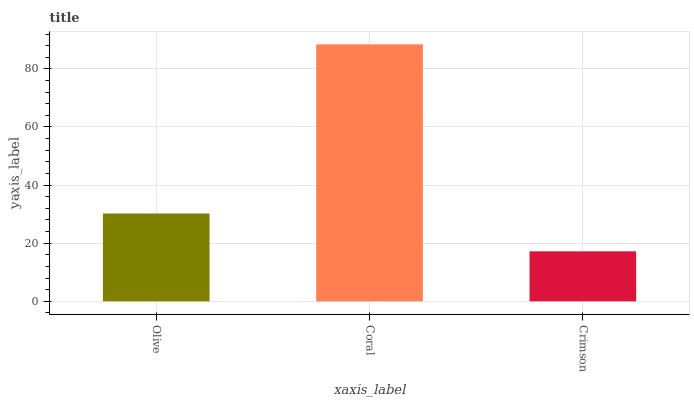Is Crimson the minimum?
Answer yes or no. Yes. Is Coral the maximum?
Answer yes or no. Yes. Is Coral the minimum?
Answer yes or no. No. Is Crimson the maximum?
Answer yes or no. No. Is Coral greater than Crimson?
Answer yes or no. Yes. Is Crimson less than Coral?
Answer yes or no. Yes. Is Crimson greater than Coral?
Answer yes or no. No. Is Coral less than Crimson?
Answer yes or no. No. Is Olive the high median?
Answer yes or no. Yes. Is Olive the low median?
Answer yes or no. Yes. Is Crimson the high median?
Answer yes or no. No. Is Coral the low median?
Answer yes or no. No. 